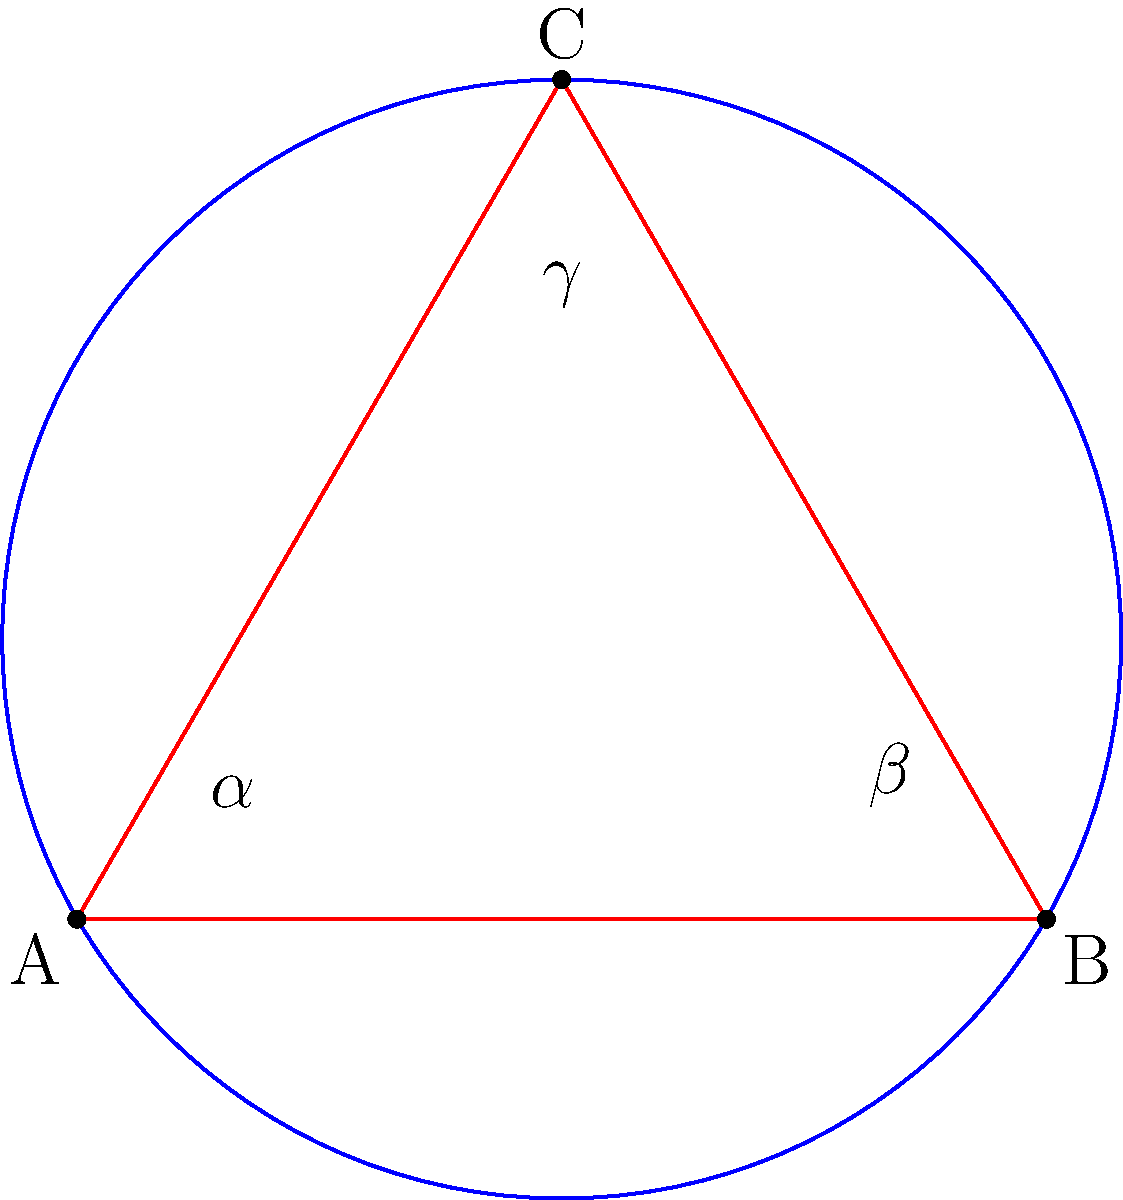In hyperbolic geometry, geometric tattoo designs often incorporate non-Euclidean shapes. Consider the hyperbolic triangle ABC shown above, where the sum of its interior angles ($\alpha + \beta + \gamma$) is less than 180°. If the area of this triangle is 0.3 radians squared, what is the sum of its interior angles in degrees? To solve this problem, we'll use the Gauss-Bonnet formula for hyperbolic triangles:

1) The Gauss-Bonnet formula states: $\alpha + \beta + \gamma = \pi - A$
   Where $A$ is the area of the hyperbolic triangle in radians squared.

2) We're given that $A = 0.3$ radians squared.

3) Substituting this into the formula:
   $\alpha + \beta + \gamma = \pi - 0.3$

4) $\pi$ is approximately 3.14159 radians.

5) Calculating:
   $\alpha + \beta + \gamma = 3.14159 - 0.3 = 2.84159$ radians

6) To convert radians to degrees, we multiply by $\frac{180}{\pi}$:
   $(2.84159) \cdot \frac{180}{\pi} = 162.84°$

Therefore, the sum of the interior angles of this hyperbolic triangle is approximately 162.84°.
Answer: 162.84° 